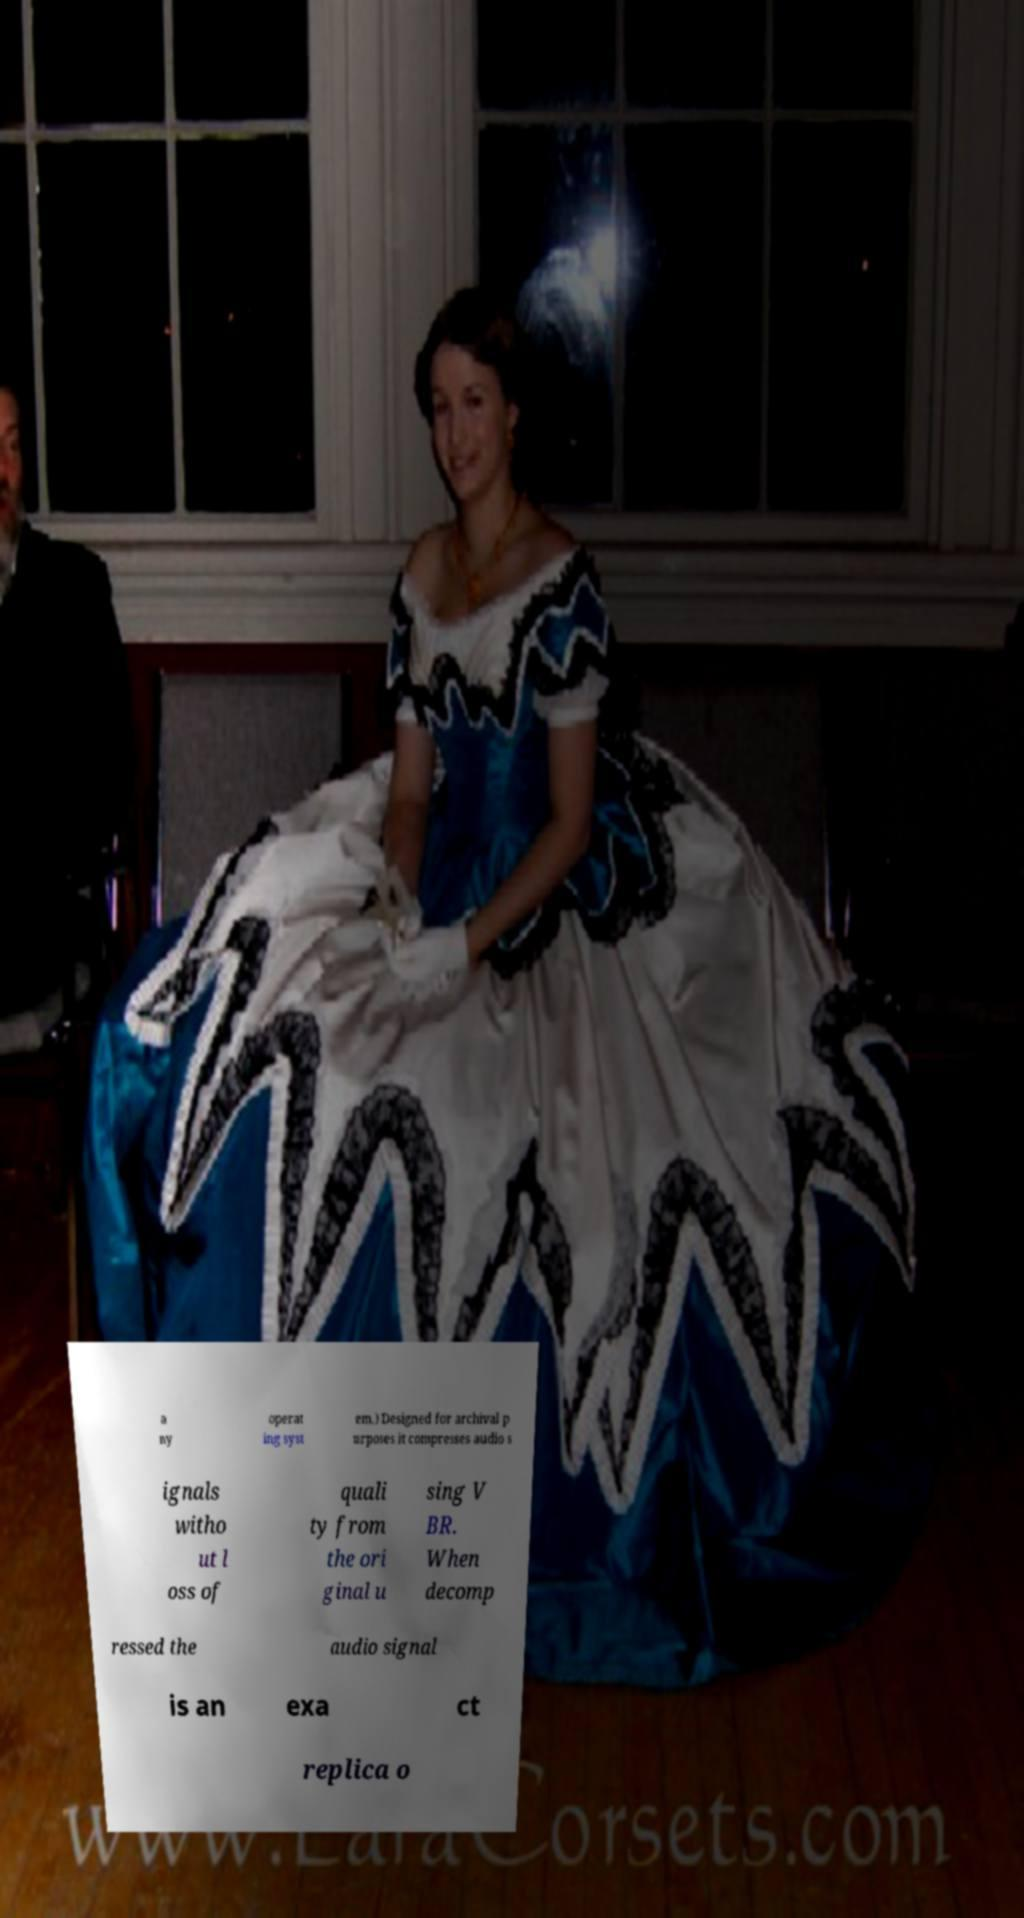Please read and relay the text visible in this image. What does it say? a ny operat ing syst em.) Designed for archival p urposes it compresses audio s ignals witho ut l oss of quali ty from the ori ginal u sing V BR. When decomp ressed the audio signal is an exa ct replica o 